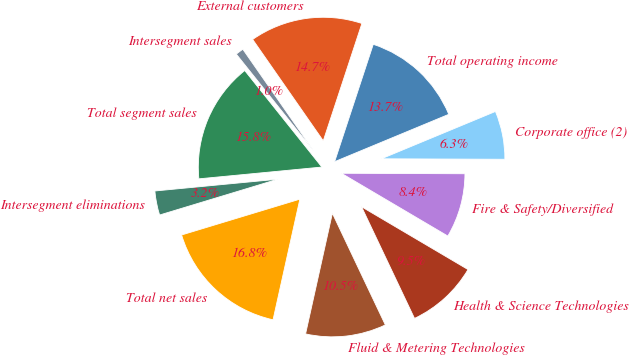<chart> <loc_0><loc_0><loc_500><loc_500><pie_chart><fcel>External customers<fcel>Intersegment sales<fcel>Total segment sales<fcel>Intersegment eliminations<fcel>Total net sales<fcel>Fluid & Metering Technologies<fcel>Health & Science Technologies<fcel>Fire & Safety/Diversified<fcel>Corporate office (2)<fcel>Total operating income<nl><fcel>14.74%<fcel>1.05%<fcel>15.79%<fcel>3.16%<fcel>16.84%<fcel>10.53%<fcel>9.47%<fcel>8.42%<fcel>6.32%<fcel>13.68%<nl></chart> 